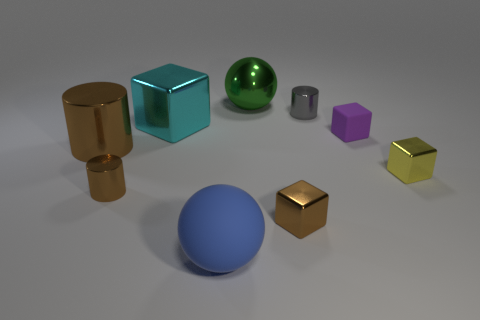What color is the big metal object in front of the metal cube that is on the left side of the blue thing?
Provide a short and direct response. Brown. Is there a cylinder on the left side of the tiny brown thing right of the large sphere that is on the right side of the blue matte sphere?
Your answer should be very brief. Yes. There is a big cylinder that is made of the same material as the tiny gray cylinder; what color is it?
Your response must be concise. Brown. What number of cyan objects are the same material as the brown block?
Your answer should be compact. 1. Do the yellow block and the tiny block that is left of the gray object have the same material?
Offer a terse response. Yes. How many things are either metal cubes that are to the right of the blue rubber thing or red matte cylinders?
Offer a very short reply. 2. There is a metal cylinder right of the brown object that is on the right side of the large ball in front of the big cylinder; what is its size?
Give a very brief answer. Small. There is another cylinder that is the same color as the large cylinder; what material is it?
Your answer should be very brief. Metal. What size is the metallic cylinder to the right of the large metal sphere to the right of the big matte object?
Ensure brevity in your answer.  Small. How many large things are brown metal cylinders or green things?
Ensure brevity in your answer.  2. 